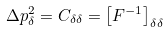Convert formula to latex. <formula><loc_0><loc_0><loc_500><loc_500>\Delta p _ { \delta } ^ { 2 } = C _ { \delta \delta } = \left [ F ^ { - 1 } \right ] _ { \delta \delta }</formula> 